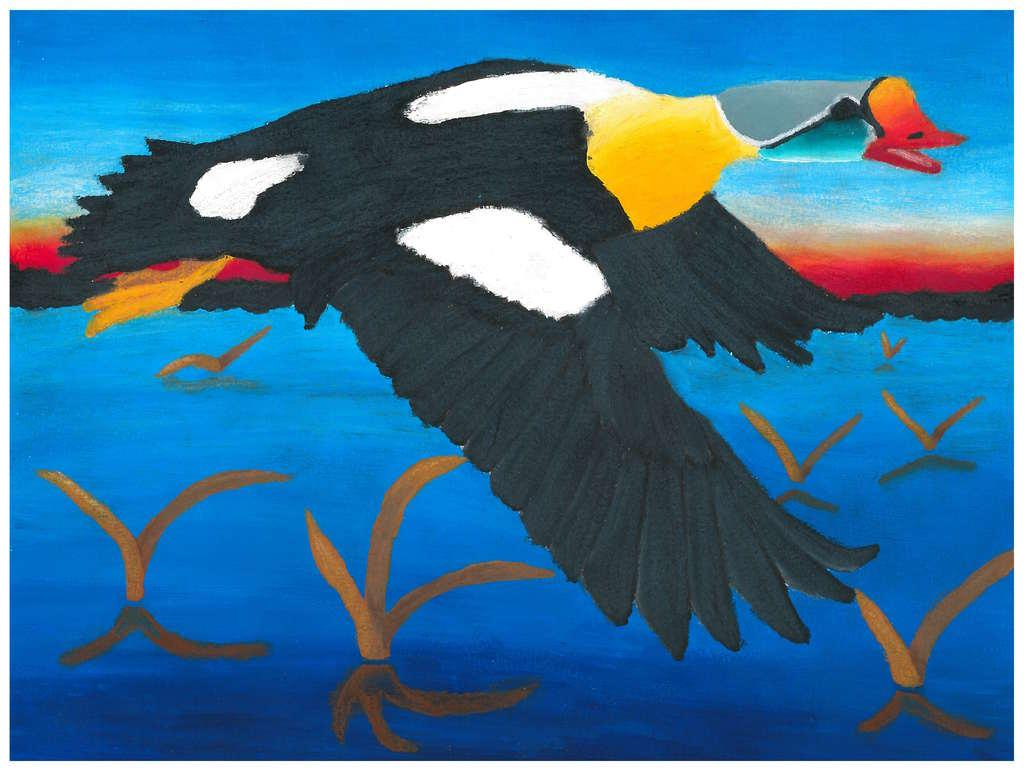What is depicted in the painting in the image? There is a painting of a bird in the image. What natural feature can be seen in the image? There is a water body visible in the image. What part of the environment is visible in the image? The sky is visible in the image. What type of horse can be seen grazing near the water body in the image? There is no horse present in the image; it features a painting of a bird and a water body. What is the taste of the bird depicted in the painting? The taste of the bird cannot be determined from the image, as it is a painting and not a real bird. 